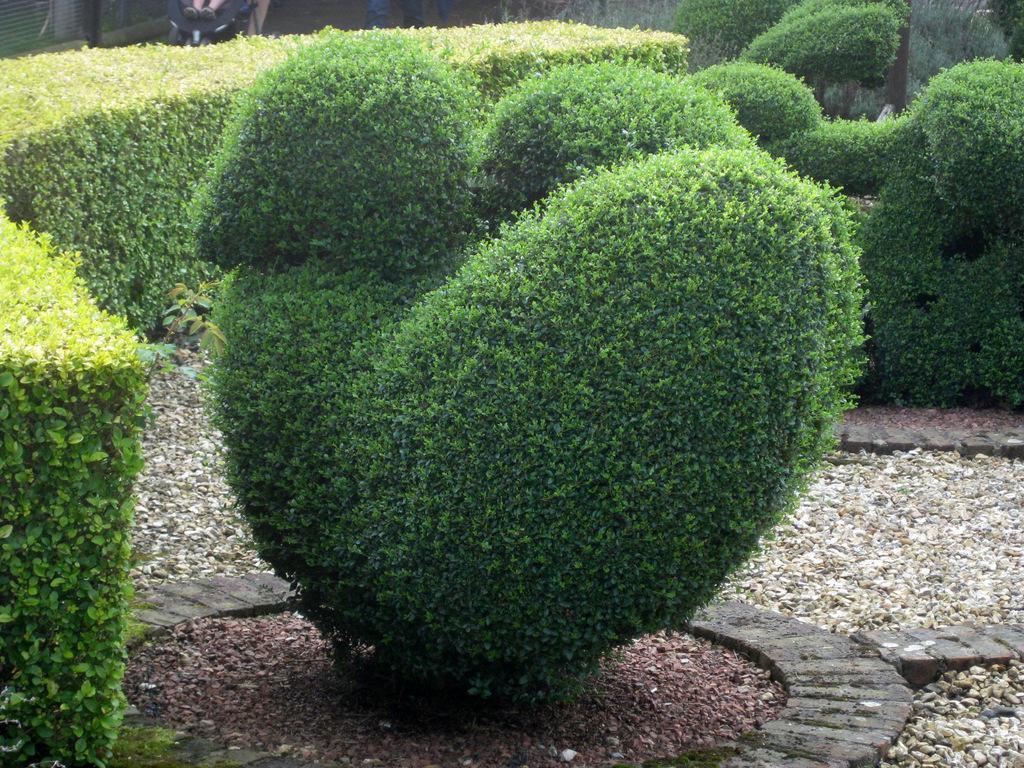In one or two sentences, can you explain what this image depicts? In this image there are some plants, and at the bottom there are some stones and sand. And in the background there are some objects. 